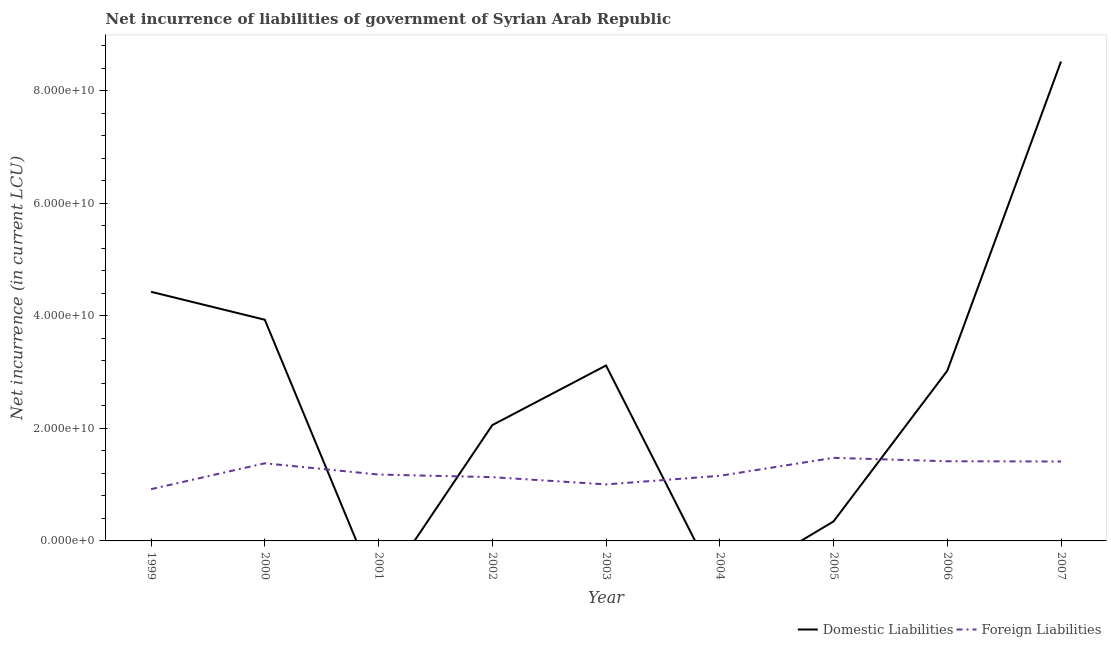What is the net incurrence of domestic liabilities in 2000?
Offer a terse response. 3.93e+1. Across all years, what is the maximum net incurrence of domestic liabilities?
Make the answer very short. 8.52e+1. Across all years, what is the minimum net incurrence of domestic liabilities?
Ensure brevity in your answer.  0. In which year was the net incurrence of foreign liabilities maximum?
Give a very brief answer. 2005. What is the total net incurrence of foreign liabilities in the graph?
Offer a very short reply. 1.11e+11. What is the difference between the net incurrence of foreign liabilities in 2001 and that in 2004?
Your answer should be very brief. 2.28e+08. What is the difference between the net incurrence of domestic liabilities in 2002 and the net incurrence of foreign liabilities in 2001?
Provide a short and direct response. 8.78e+09. What is the average net incurrence of foreign liabilities per year?
Your response must be concise. 1.23e+1. In the year 2007, what is the difference between the net incurrence of domestic liabilities and net incurrence of foreign liabilities?
Your response must be concise. 7.11e+1. What is the ratio of the net incurrence of foreign liabilities in 2001 to that in 2003?
Offer a terse response. 1.17. Is the net incurrence of foreign liabilities in 2002 less than that in 2004?
Make the answer very short. Yes. Is the difference between the net incurrence of domestic liabilities in 2000 and 2007 greater than the difference between the net incurrence of foreign liabilities in 2000 and 2007?
Your answer should be compact. No. What is the difference between the highest and the second highest net incurrence of foreign liabilities?
Offer a very short reply. 6.10e+08. What is the difference between the highest and the lowest net incurrence of domestic liabilities?
Your answer should be very brief. 8.52e+1. Is the sum of the net incurrence of foreign liabilities in 2002 and 2003 greater than the maximum net incurrence of domestic liabilities across all years?
Offer a very short reply. No. Is the net incurrence of domestic liabilities strictly less than the net incurrence of foreign liabilities over the years?
Provide a succinct answer. No. How many lines are there?
Keep it short and to the point. 2. Are the values on the major ticks of Y-axis written in scientific E-notation?
Provide a short and direct response. Yes. Where does the legend appear in the graph?
Provide a short and direct response. Bottom right. What is the title of the graph?
Ensure brevity in your answer.  Net incurrence of liabilities of government of Syrian Arab Republic. Does "Drinking water services" appear as one of the legend labels in the graph?
Provide a short and direct response. No. What is the label or title of the X-axis?
Offer a very short reply. Year. What is the label or title of the Y-axis?
Provide a short and direct response. Net incurrence (in current LCU). What is the Net incurrence (in current LCU) in Domestic Liabilities in 1999?
Offer a very short reply. 4.43e+1. What is the Net incurrence (in current LCU) in Foreign Liabilities in 1999?
Make the answer very short. 9.20e+09. What is the Net incurrence (in current LCU) of Domestic Liabilities in 2000?
Offer a terse response. 3.93e+1. What is the Net incurrence (in current LCU) of Foreign Liabilities in 2000?
Your response must be concise. 1.38e+1. What is the Net incurrence (in current LCU) in Foreign Liabilities in 2001?
Provide a short and direct response. 1.18e+1. What is the Net incurrence (in current LCU) of Domestic Liabilities in 2002?
Make the answer very short. 2.06e+1. What is the Net incurrence (in current LCU) in Foreign Liabilities in 2002?
Offer a terse response. 1.13e+1. What is the Net incurrence (in current LCU) in Domestic Liabilities in 2003?
Offer a very short reply. 3.12e+1. What is the Net incurrence (in current LCU) in Foreign Liabilities in 2003?
Keep it short and to the point. 1.00e+1. What is the Net incurrence (in current LCU) of Foreign Liabilities in 2004?
Make the answer very short. 1.16e+1. What is the Net incurrence (in current LCU) in Domestic Liabilities in 2005?
Give a very brief answer. 3.46e+09. What is the Net incurrence (in current LCU) in Foreign Liabilities in 2005?
Provide a succinct answer. 1.48e+1. What is the Net incurrence (in current LCU) in Domestic Liabilities in 2006?
Keep it short and to the point. 3.02e+1. What is the Net incurrence (in current LCU) in Foreign Liabilities in 2006?
Ensure brevity in your answer.  1.42e+1. What is the Net incurrence (in current LCU) in Domestic Liabilities in 2007?
Make the answer very short. 8.52e+1. What is the Net incurrence (in current LCU) in Foreign Liabilities in 2007?
Make the answer very short. 1.41e+1. Across all years, what is the maximum Net incurrence (in current LCU) in Domestic Liabilities?
Provide a succinct answer. 8.52e+1. Across all years, what is the maximum Net incurrence (in current LCU) of Foreign Liabilities?
Make the answer very short. 1.48e+1. Across all years, what is the minimum Net incurrence (in current LCU) of Domestic Liabilities?
Keep it short and to the point. 0. Across all years, what is the minimum Net incurrence (in current LCU) in Foreign Liabilities?
Your answer should be very brief. 9.20e+09. What is the total Net incurrence (in current LCU) of Domestic Liabilities in the graph?
Offer a terse response. 2.54e+11. What is the total Net incurrence (in current LCU) of Foreign Liabilities in the graph?
Your response must be concise. 1.11e+11. What is the difference between the Net incurrence (in current LCU) of Domestic Liabilities in 1999 and that in 2000?
Give a very brief answer. 4.97e+09. What is the difference between the Net incurrence (in current LCU) in Foreign Liabilities in 1999 and that in 2000?
Keep it short and to the point. -4.60e+09. What is the difference between the Net incurrence (in current LCU) of Foreign Liabilities in 1999 and that in 2001?
Make the answer very short. -2.60e+09. What is the difference between the Net incurrence (in current LCU) of Domestic Liabilities in 1999 and that in 2002?
Offer a terse response. 2.37e+1. What is the difference between the Net incurrence (in current LCU) of Foreign Liabilities in 1999 and that in 2002?
Make the answer very short. -2.14e+09. What is the difference between the Net incurrence (in current LCU) in Domestic Liabilities in 1999 and that in 2003?
Your answer should be very brief. 1.31e+1. What is the difference between the Net incurrence (in current LCU) in Foreign Liabilities in 1999 and that in 2003?
Give a very brief answer. -8.47e+08. What is the difference between the Net incurrence (in current LCU) of Foreign Liabilities in 1999 and that in 2004?
Give a very brief answer. -2.37e+09. What is the difference between the Net incurrence (in current LCU) in Domestic Liabilities in 1999 and that in 2005?
Your answer should be compact. 4.08e+1. What is the difference between the Net incurrence (in current LCU) in Foreign Liabilities in 1999 and that in 2005?
Provide a succinct answer. -5.57e+09. What is the difference between the Net incurrence (in current LCU) in Domestic Liabilities in 1999 and that in 2006?
Your answer should be very brief. 1.40e+1. What is the difference between the Net incurrence (in current LCU) of Foreign Liabilities in 1999 and that in 2006?
Provide a short and direct response. -4.96e+09. What is the difference between the Net incurrence (in current LCU) in Domestic Liabilities in 1999 and that in 2007?
Provide a succinct answer. -4.09e+1. What is the difference between the Net incurrence (in current LCU) in Foreign Liabilities in 1999 and that in 2007?
Give a very brief answer. -4.92e+09. What is the difference between the Net incurrence (in current LCU) in Domestic Liabilities in 2000 and that in 2002?
Ensure brevity in your answer.  1.87e+1. What is the difference between the Net incurrence (in current LCU) in Foreign Liabilities in 2000 and that in 2002?
Your answer should be compact. 2.46e+09. What is the difference between the Net incurrence (in current LCU) in Domestic Liabilities in 2000 and that in 2003?
Give a very brief answer. 8.13e+09. What is the difference between the Net incurrence (in current LCU) of Foreign Liabilities in 2000 and that in 2003?
Your response must be concise. 3.75e+09. What is the difference between the Net incurrence (in current LCU) of Foreign Liabilities in 2000 and that in 2004?
Provide a short and direct response. 2.23e+09. What is the difference between the Net incurrence (in current LCU) in Domestic Liabilities in 2000 and that in 2005?
Your answer should be compact. 3.59e+1. What is the difference between the Net incurrence (in current LCU) in Foreign Liabilities in 2000 and that in 2005?
Make the answer very short. -9.69e+08. What is the difference between the Net incurrence (in current LCU) in Domestic Liabilities in 2000 and that in 2006?
Make the answer very short. 9.08e+09. What is the difference between the Net incurrence (in current LCU) in Foreign Liabilities in 2000 and that in 2006?
Your answer should be compact. -3.59e+08. What is the difference between the Net incurrence (in current LCU) in Domestic Liabilities in 2000 and that in 2007?
Give a very brief answer. -4.59e+1. What is the difference between the Net incurrence (in current LCU) in Foreign Liabilities in 2000 and that in 2007?
Make the answer very short. -3.19e+08. What is the difference between the Net incurrence (in current LCU) in Foreign Liabilities in 2001 and that in 2002?
Make the answer very short. 4.64e+08. What is the difference between the Net incurrence (in current LCU) in Foreign Liabilities in 2001 and that in 2003?
Offer a terse response. 1.75e+09. What is the difference between the Net incurrence (in current LCU) in Foreign Liabilities in 2001 and that in 2004?
Provide a succinct answer. 2.28e+08. What is the difference between the Net incurrence (in current LCU) of Foreign Liabilities in 2001 and that in 2005?
Offer a terse response. -2.97e+09. What is the difference between the Net incurrence (in current LCU) in Foreign Liabilities in 2001 and that in 2006?
Ensure brevity in your answer.  -2.36e+09. What is the difference between the Net incurrence (in current LCU) in Foreign Liabilities in 2001 and that in 2007?
Offer a terse response. -2.32e+09. What is the difference between the Net incurrence (in current LCU) of Domestic Liabilities in 2002 and that in 2003?
Ensure brevity in your answer.  -1.06e+1. What is the difference between the Net incurrence (in current LCU) in Foreign Liabilities in 2002 and that in 2003?
Your response must be concise. 1.29e+09. What is the difference between the Net incurrence (in current LCU) in Foreign Liabilities in 2002 and that in 2004?
Give a very brief answer. -2.36e+08. What is the difference between the Net incurrence (in current LCU) in Domestic Liabilities in 2002 and that in 2005?
Give a very brief answer. 1.71e+1. What is the difference between the Net incurrence (in current LCU) in Foreign Liabilities in 2002 and that in 2005?
Ensure brevity in your answer.  -3.43e+09. What is the difference between the Net incurrence (in current LCU) of Domestic Liabilities in 2002 and that in 2006?
Keep it short and to the point. -9.66e+09. What is the difference between the Net incurrence (in current LCU) of Foreign Liabilities in 2002 and that in 2006?
Provide a short and direct response. -2.82e+09. What is the difference between the Net incurrence (in current LCU) in Domestic Liabilities in 2002 and that in 2007?
Your answer should be very brief. -6.46e+1. What is the difference between the Net incurrence (in current LCU) of Foreign Liabilities in 2002 and that in 2007?
Offer a terse response. -2.78e+09. What is the difference between the Net incurrence (in current LCU) in Foreign Liabilities in 2003 and that in 2004?
Give a very brief answer. -1.52e+09. What is the difference between the Net incurrence (in current LCU) of Domestic Liabilities in 2003 and that in 2005?
Your answer should be compact. 2.77e+1. What is the difference between the Net incurrence (in current LCU) of Foreign Liabilities in 2003 and that in 2005?
Keep it short and to the point. -4.72e+09. What is the difference between the Net incurrence (in current LCU) of Domestic Liabilities in 2003 and that in 2006?
Provide a short and direct response. 9.44e+08. What is the difference between the Net incurrence (in current LCU) in Foreign Liabilities in 2003 and that in 2006?
Offer a terse response. -4.11e+09. What is the difference between the Net incurrence (in current LCU) in Domestic Liabilities in 2003 and that in 2007?
Your answer should be compact. -5.40e+1. What is the difference between the Net incurrence (in current LCU) of Foreign Liabilities in 2003 and that in 2007?
Offer a very short reply. -4.07e+09. What is the difference between the Net incurrence (in current LCU) of Foreign Liabilities in 2004 and that in 2005?
Ensure brevity in your answer.  -3.20e+09. What is the difference between the Net incurrence (in current LCU) of Foreign Liabilities in 2004 and that in 2006?
Provide a short and direct response. -2.59e+09. What is the difference between the Net incurrence (in current LCU) of Foreign Liabilities in 2004 and that in 2007?
Ensure brevity in your answer.  -2.55e+09. What is the difference between the Net incurrence (in current LCU) of Domestic Liabilities in 2005 and that in 2006?
Your response must be concise. -2.68e+1. What is the difference between the Net incurrence (in current LCU) in Foreign Liabilities in 2005 and that in 2006?
Provide a succinct answer. 6.10e+08. What is the difference between the Net incurrence (in current LCU) of Domestic Liabilities in 2005 and that in 2007?
Your answer should be compact. -8.18e+1. What is the difference between the Net incurrence (in current LCU) of Foreign Liabilities in 2005 and that in 2007?
Your answer should be very brief. 6.50e+08. What is the difference between the Net incurrence (in current LCU) in Domestic Liabilities in 2006 and that in 2007?
Offer a very short reply. -5.50e+1. What is the difference between the Net incurrence (in current LCU) of Foreign Liabilities in 2006 and that in 2007?
Your answer should be very brief. 4.00e+07. What is the difference between the Net incurrence (in current LCU) of Domestic Liabilities in 1999 and the Net incurrence (in current LCU) of Foreign Liabilities in 2000?
Offer a very short reply. 3.05e+1. What is the difference between the Net incurrence (in current LCU) in Domestic Liabilities in 1999 and the Net incurrence (in current LCU) in Foreign Liabilities in 2001?
Your response must be concise. 3.25e+1. What is the difference between the Net incurrence (in current LCU) of Domestic Liabilities in 1999 and the Net incurrence (in current LCU) of Foreign Liabilities in 2002?
Keep it short and to the point. 3.29e+1. What is the difference between the Net incurrence (in current LCU) in Domestic Liabilities in 1999 and the Net incurrence (in current LCU) in Foreign Liabilities in 2003?
Offer a very short reply. 3.42e+1. What is the difference between the Net incurrence (in current LCU) of Domestic Liabilities in 1999 and the Net incurrence (in current LCU) of Foreign Liabilities in 2004?
Provide a succinct answer. 3.27e+1. What is the difference between the Net incurrence (in current LCU) of Domestic Liabilities in 1999 and the Net incurrence (in current LCU) of Foreign Liabilities in 2005?
Ensure brevity in your answer.  2.95e+1. What is the difference between the Net incurrence (in current LCU) of Domestic Liabilities in 1999 and the Net incurrence (in current LCU) of Foreign Liabilities in 2006?
Keep it short and to the point. 3.01e+1. What is the difference between the Net incurrence (in current LCU) of Domestic Liabilities in 1999 and the Net incurrence (in current LCU) of Foreign Liabilities in 2007?
Keep it short and to the point. 3.02e+1. What is the difference between the Net incurrence (in current LCU) of Domestic Liabilities in 2000 and the Net incurrence (in current LCU) of Foreign Liabilities in 2001?
Make the answer very short. 2.75e+1. What is the difference between the Net incurrence (in current LCU) in Domestic Liabilities in 2000 and the Net incurrence (in current LCU) in Foreign Liabilities in 2002?
Your answer should be compact. 2.80e+1. What is the difference between the Net incurrence (in current LCU) of Domestic Liabilities in 2000 and the Net incurrence (in current LCU) of Foreign Liabilities in 2003?
Your answer should be very brief. 2.93e+1. What is the difference between the Net incurrence (in current LCU) of Domestic Liabilities in 2000 and the Net incurrence (in current LCU) of Foreign Liabilities in 2004?
Keep it short and to the point. 2.77e+1. What is the difference between the Net incurrence (in current LCU) in Domestic Liabilities in 2000 and the Net incurrence (in current LCU) in Foreign Liabilities in 2005?
Make the answer very short. 2.45e+1. What is the difference between the Net incurrence (in current LCU) in Domestic Liabilities in 2000 and the Net incurrence (in current LCU) in Foreign Liabilities in 2006?
Offer a terse response. 2.52e+1. What is the difference between the Net incurrence (in current LCU) in Domestic Liabilities in 2000 and the Net incurrence (in current LCU) in Foreign Liabilities in 2007?
Offer a very short reply. 2.52e+1. What is the difference between the Net incurrence (in current LCU) in Domestic Liabilities in 2002 and the Net incurrence (in current LCU) in Foreign Liabilities in 2003?
Your answer should be very brief. 1.05e+1. What is the difference between the Net incurrence (in current LCU) of Domestic Liabilities in 2002 and the Net incurrence (in current LCU) of Foreign Liabilities in 2004?
Offer a very short reply. 9.01e+09. What is the difference between the Net incurrence (in current LCU) of Domestic Liabilities in 2002 and the Net incurrence (in current LCU) of Foreign Liabilities in 2005?
Give a very brief answer. 5.81e+09. What is the difference between the Net incurrence (in current LCU) in Domestic Liabilities in 2002 and the Net incurrence (in current LCU) in Foreign Liabilities in 2006?
Offer a very short reply. 6.42e+09. What is the difference between the Net incurrence (in current LCU) of Domestic Liabilities in 2002 and the Net incurrence (in current LCU) of Foreign Liabilities in 2007?
Make the answer very short. 6.46e+09. What is the difference between the Net incurrence (in current LCU) in Domestic Liabilities in 2003 and the Net incurrence (in current LCU) in Foreign Liabilities in 2004?
Offer a very short reply. 1.96e+1. What is the difference between the Net incurrence (in current LCU) of Domestic Liabilities in 2003 and the Net incurrence (in current LCU) of Foreign Liabilities in 2005?
Keep it short and to the point. 1.64e+1. What is the difference between the Net incurrence (in current LCU) of Domestic Liabilities in 2003 and the Net incurrence (in current LCU) of Foreign Liabilities in 2006?
Provide a succinct answer. 1.70e+1. What is the difference between the Net incurrence (in current LCU) in Domestic Liabilities in 2003 and the Net incurrence (in current LCU) in Foreign Liabilities in 2007?
Offer a very short reply. 1.71e+1. What is the difference between the Net incurrence (in current LCU) of Domestic Liabilities in 2005 and the Net incurrence (in current LCU) of Foreign Liabilities in 2006?
Offer a very short reply. -1.07e+1. What is the difference between the Net incurrence (in current LCU) in Domestic Liabilities in 2005 and the Net incurrence (in current LCU) in Foreign Liabilities in 2007?
Ensure brevity in your answer.  -1.07e+1. What is the difference between the Net incurrence (in current LCU) of Domestic Liabilities in 2006 and the Net incurrence (in current LCU) of Foreign Liabilities in 2007?
Your answer should be compact. 1.61e+1. What is the average Net incurrence (in current LCU) of Domestic Liabilities per year?
Give a very brief answer. 2.83e+1. What is the average Net incurrence (in current LCU) in Foreign Liabilities per year?
Give a very brief answer. 1.23e+1. In the year 1999, what is the difference between the Net incurrence (in current LCU) in Domestic Liabilities and Net incurrence (in current LCU) in Foreign Liabilities?
Provide a succinct answer. 3.51e+1. In the year 2000, what is the difference between the Net incurrence (in current LCU) of Domestic Liabilities and Net incurrence (in current LCU) of Foreign Liabilities?
Provide a succinct answer. 2.55e+1. In the year 2002, what is the difference between the Net incurrence (in current LCU) of Domestic Liabilities and Net incurrence (in current LCU) of Foreign Liabilities?
Give a very brief answer. 9.25e+09. In the year 2003, what is the difference between the Net incurrence (in current LCU) of Domestic Liabilities and Net incurrence (in current LCU) of Foreign Liabilities?
Keep it short and to the point. 2.11e+1. In the year 2005, what is the difference between the Net incurrence (in current LCU) of Domestic Liabilities and Net incurrence (in current LCU) of Foreign Liabilities?
Provide a succinct answer. -1.13e+1. In the year 2006, what is the difference between the Net incurrence (in current LCU) in Domestic Liabilities and Net incurrence (in current LCU) in Foreign Liabilities?
Keep it short and to the point. 1.61e+1. In the year 2007, what is the difference between the Net incurrence (in current LCU) of Domestic Liabilities and Net incurrence (in current LCU) of Foreign Liabilities?
Your answer should be very brief. 7.11e+1. What is the ratio of the Net incurrence (in current LCU) in Domestic Liabilities in 1999 to that in 2000?
Give a very brief answer. 1.13. What is the ratio of the Net incurrence (in current LCU) of Foreign Liabilities in 1999 to that in 2000?
Make the answer very short. 0.67. What is the ratio of the Net incurrence (in current LCU) in Foreign Liabilities in 1999 to that in 2001?
Make the answer very short. 0.78. What is the ratio of the Net incurrence (in current LCU) in Domestic Liabilities in 1999 to that in 2002?
Provide a short and direct response. 2.15. What is the ratio of the Net incurrence (in current LCU) of Foreign Liabilities in 1999 to that in 2002?
Your answer should be compact. 0.81. What is the ratio of the Net incurrence (in current LCU) in Domestic Liabilities in 1999 to that in 2003?
Offer a very short reply. 1.42. What is the ratio of the Net incurrence (in current LCU) of Foreign Liabilities in 1999 to that in 2003?
Ensure brevity in your answer.  0.92. What is the ratio of the Net incurrence (in current LCU) of Foreign Liabilities in 1999 to that in 2004?
Your answer should be very brief. 0.8. What is the ratio of the Net incurrence (in current LCU) in Domestic Liabilities in 1999 to that in 2005?
Ensure brevity in your answer.  12.78. What is the ratio of the Net incurrence (in current LCU) in Foreign Liabilities in 1999 to that in 2005?
Your answer should be very brief. 0.62. What is the ratio of the Net incurrence (in current LCU) of Domestic Liabilities in 1999 to that in 2006?
Offer a very short reply. 1.46. What is the ratio of the Net incurrence (in current LCU) in Foreign Liabilities in 1999 to that in 2006?
Offer a terse response. 0.65. What is the ratio of the Net incurrence (in current LCU) of Domestic Liabilities in 1999 to that in 2007?
Ensure brevity in your answer.  0.52. What is the ratio of the Net incurrence (in current LCU) in Foreign Liabilities in 1999 to that in 2007?
Your response must be concise. 0.65. What is the ratio of the Net incurrence (in current LCU) in Foreign Liabilities in 2000 to that in 2001?
Your answer should be compact. 1.17. What is the ratio of the Net incurrence (in current LCU) in Domestic Liabilities in 2000 to that in 2002?
Your response must be concise. 1.91. What is the ratio of the Net incurrence (in current LCU) of Foreign Liabilities in 2000 to that in 2002?
Provide a short and direct response. 1.22. What is the ratio of the Net incurrence (in current LCU) in Domestic Liabilities in 2000 to that in 2003?
Give a very brief answer. 1.26. What is the ratio of the Net incurrence (in current LCU) in Foreign Liabilities in 2000 to that in 2003?
Keep it short and to the point. 1.37. What is the ratio of the Net incurrence (in current LCU) in Foreign Liabilities in 2000 to that in 2004?
Give a very brief answer. 1.19. What is the ratio of the Net incurrence (in current LCU) in Domestic Liabilities in 2000 to that in 2005?
Provide a succinct answer. 11.35. What is the ratio of the Net incurrence (in current LCU) in Foreign Liabilities in 2000 to that in 2005?
Offer a very short reply. 0.93. What is the ratio of the Net incurrence (in current LCU) in Domestic Liabilities in 2000 to that in 2006?
Your response must be concise. 1.3. What is the ratio of the Net incurrence (in current LCU) in Foreign Liabilities in 2000 to that in 2006?
Give a very brief answer. 0.97. What is the ratio of the Net incurrence (in current LCU) of Domestic Liabilities in 2000 to that in 2007?
Provide a succinct answer. 0.46. What is the ratio of the Net incurrence (in current LCU) in Foreign Liabilities in 2000 to that in 2007?
Your answer should be compact. 0.98. What is the ratio of the Net incurrence (in current LCU) in Foreign Liabilities in 2001 to that in 2002?
Provide a short and direct response. 1.04. What is the ratio of the Net incurrence (in current LCU) in Foreign Liabilities in 2001 to that in 2003?
Give a very brief answer. 1.17. What is the ratio of the Net incurrence (in current LCU) in Foreign Liabilities in 2001 to that in 2004?
Offer a very short reply. 1.02. What is the ratio of the Net incurrence (in current LCU) of Foreign Liabilities in 2001 to that in 2005?
Your answer should be very brief. 0.8. What is the ratio of the Net incurrence (in current LCU) of Foreign Liabilities in 2001 to that in 2006?
Give a very brief answer. 0.83. What is the ratio of the Net incurrence (in current LCU) in Foreign Liabilities in 2001 to that in 2007?
Make the answer very short. 0.84. What is the ratio of the Net incurrence (in current LCU) in Domestic Liabilities in 2002 to that in 2003?
Provide a short and direct response. 0.66. What is the ratio of the Net incurrence (in current LCU) of Foreign Liabilities in 2002 to that in 2003?
Offer a very short reply. 1.13. What is the ratio of the Net incurrence (in current LCU) of Foreign Liabilities in 2002 to that in 2004?
Give a very brief answer. 0.98. What is the ratio of the Net incurrence (in current LCU) in Domestic Liabilities in 2002 to that in 2005?
Keep it short and to the point. 5.94. What is the ratio of the Net incurrence (in current LCU) in Foreign Liabilities in 2002 to that in 2005?
Keep it short and to the point. 0.77. What is the ratio of the Net incurrence (in current LCU) of Domestic Liabilities in 2002 to that in 2006?
Make the answer very short. 0.68. What is the ratio of the Net incurrence (in current LCU) in Foreign Liabilities in 2002 to that in 2006?
Provide a short and direct response. 0.8. What is the ratio of the Net incurrence (in current LCU) of Domestic Liabilities in 2002 to that in 2007?
Provide a succinct answer. 0.24. What is the ratio of the Net incurrence (in current LCU) of Foreign Liabilities in 2002 to that in 2007?
Your answer should be very brief. 0.8. What is the ratio of the Net incurrence (in current LCU) in Foreign Liabilities in 2003 to that in 2004?
Offer a very short reply. 0.87. What is the ratio of the Net incurrence (in current LCU) in Domestic Liabilities in 2003 to that in 2005?
Your answer should be compact. 9. What is the ratio of the Net incurrence (in current LCU) in Foreign Liabilities in 2003 to that in 2005?
Make the answer very short. 0.68. What is the ratio of the Net incurrence (in current LCU) in Domestic Liabilities in 2003 to that in 2006?
Your answer should be compact. 1.03. What is the ratio of the Net incurrence (in current LCU) of Foreign Liabilities in 2003 to that in 2006?
Your answer should be compact. 0.71. What is the ratio of the Net incurrence (in current LCU) of Domestic Liabilities in 2003 to that in 2007?
Give a very brief answer. 0.37. What is the ratio of the Net incurrence (in current LCU) of Foreign Liabilities in 2003 to that in 2007?
Offer a terse response. 0.71. What is the ratio of the Net incurrence (in current LCU) of Foreign Liabilities in 2004 to that in 2005?
Offer a very short reply. 0.78. What is the ratio of the Net incurrence (in current LCU) in Foreign Liabilities in 2004 to that in 2006?
Make the answer very short. 0.82. What is the ratio of the Net incurrence (in current LCU) in Foreign Liabilities in 2004 to that in 2007?
Your answer should be compact. 0.82. What is the ratio of the Net incurrence (in current LCU) in Domestic Liabilities in 2005 to that in 2006?
Offer a terse response. 0.11. What is the ratio of the Net incurrence (in current LCU) in Foreign Liabilities in 2005 to that in 2006?
Your response must be concise. 1.04. What is the ratio of the Net incurrence (in current LCU) in Domestic Liabilities in 2005 to that in 2007?
Offer a very short reply. 0.04. What is the ratio of the Net incurrence (in current LCU) in Foreign Liabilities in 2005 to that in 2007?
Your answer should be very brief. 1.05. What is the ratio of the Net incurrence (in current LCU) of Domestic Liabilities in 2006 to that in 2007?
Your answer should be very brief. 0.35. What is the ratio of the Net incurrence (in current LCU) in Foreign Liabilities in 2006 to that in 2007?
Give a very brief answer. 1. What is the difference between the highest and the second highest Net incurrence (in current LCU) of Domestic Liabilities?
Keep it short and to the point. 4.09e+1. What is the difference between the highest and the second highest Net incurrence (in current LCU) in Foreign Liabilities?
Your answer should be compact. 6.10e+08. What is the difference between the highest and the lowest Net incurrence (in current LCU) of Domestic Liabilities?
Provide a succinct answer. 8.52e+1. What is the difference between the highest and the lowest Net incurrence (in current LCU) of Foreign Liabilities?
Make the answer very short. 5.57e+09. 